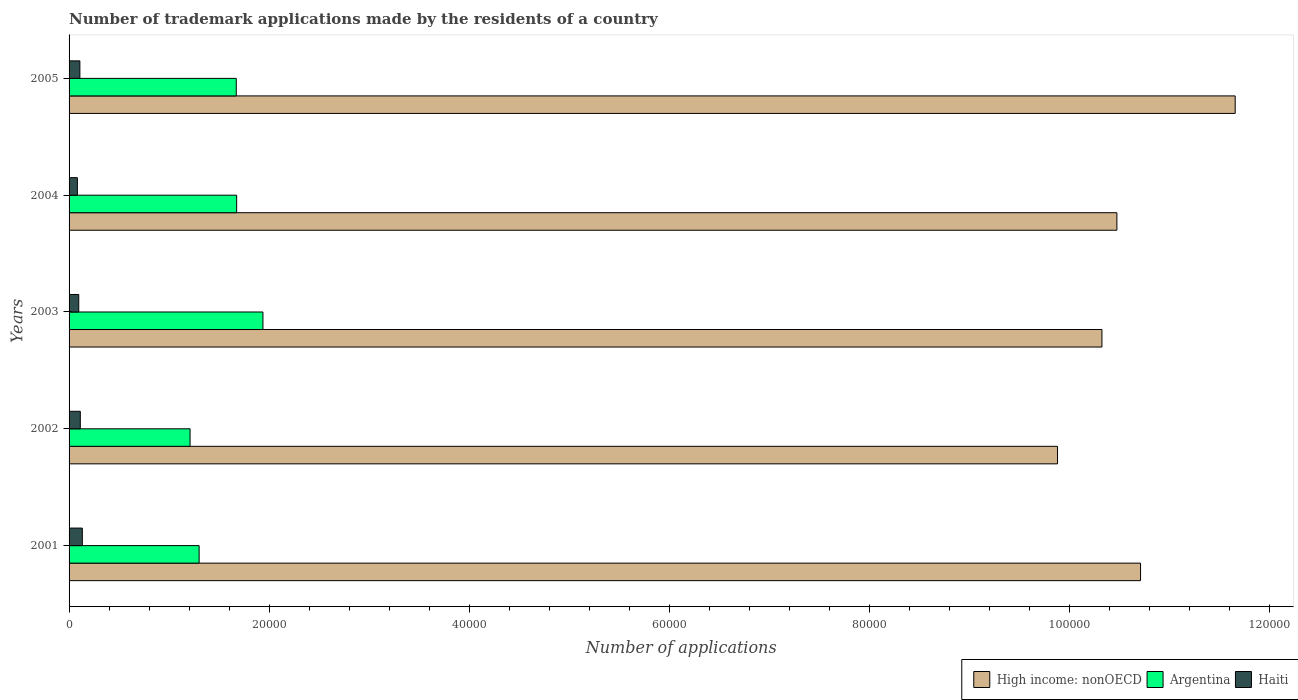Are the number of bars per tick equal to the number of legend labels?
Offer a terse response. Yes. Are the number of bars on each tick of the Y-axis equal?
Keep it short and to the point. Yes. What is the number of trademark applications made by the residents in Argentina in 2005?
Make the answer very short. 1.67e+04. Across all years, what is the maximum number of trademark applications made by the residents in Argentina?
Offer a very short reply. 1.94e+04. Across all years, what is the minimum number of trademark applications made by the residents in High income: nonOECD?
Offer a very short reply. 9.88e+04. In which year was the number of trademark applications made by the residents in Argentina minimum?
Offer a very short reply. 2002. What is the total number of trademark applications made by the residents in High income: nonOECD in the graph?
Make the answer very short. 5.30e+05. What is the difference between the number of trademark applications made by the residents in High income: nonOECD in 2001 and that in 2005?
Provide a short and direct response. -9458. What is the difference between the number of trademark applications made by the residents in Haiti in 2004 and the number of trademark applications made by the residents in High income: nonOECD in 2001?
Provide a short and direct response. -1.06e+05. What is the average number of trademark applications made by the residents in Argentina per year?
Your answer should be compact. 1.56e+04. In the year 2003, what is the difference between the number of trademark applications made by the residents in Haiti and number of trademark applications made by the residents in High income: nonOECD?
Keep it short and to the point. -1.02e+05. In how many years, is the number of trademark applications made by the residents in Haiti greater than 112000 ?
Offer a terse response. 0. What is the ratio of the number of trademark applications made by the residents in Argentina in 2001 to that in 2004?
Your response must be concise. 0.78. Is the number of trademark applications made by the residents in Argentina in 2001 less than that in 2004?
Your answer should be very brief. Yes. What is the difference between the highest and the second highest number of trademark applications made by the residents in High income: nonOECD?
Keep it short and to the point. 9458. What is the difference between the highest and the lowest number of trademark applications made by the residents in Haiti?
Your answer should be compact. 495. What does the 1st bar from the top in 2001 represents?
Your answer should be compact. Haiti. What does the 2nd bar from the bottom in 2002 represents?
Offer a terse response. Argentina. Is it the case that in every year, the sum of the number of trademark applications made by the residents in Argentina and number of trademark applications made by the residents in High income: nonOECD is greater than the number of trademark applications made by the residents in Haiti?
Keep it short and to the point. Yes. How many bars are there?
Give a very brief answer. 15. How many years are there in the graph?
Your response must be concise. 5. What is the difference between two consecutive major ticks on the X-axis?
Offer a very short reply. 2.00e+04. Does the graph contain grids?
Offer a terse response. No. Where does the legend appear in the graph?
Your answer should be very brief. Bottom right. How many legend labels are there?
Your answer should be very brief. 3. How are the legend labels stacked?
Provide a short and direct response. Horizontal. What is the title of the graph?
Provide a succinct answer. Number of trademark applications made by the residents of a country. Does "Mozambique" appear as one of the legend labels in the graph?
Provide a succinct answer. No. What is the label or title of the X-axis?
Offer a very short reply. Number of applications. What is the Number of applications in High income: nonOECD in 2001?
Ensure brevity in your answer.  1.07e+05. What is the Number of applications in Argentina in 2001?
Provide a succinct answer. 1.30e+04. What is the Number of applications of Haiti in 2001?
Your answer should be compact. 1325. What is the Number of applications in High income: nonOECD in 2002?
Provide a succinct answer. 9.88e+04. What is the Number of applications in Argentina in 2002?
Your answer should be very brief. 1.21e+04. What is the Number of applications of Haiti in 2002?
Provide a short and direct response. 1122. What is the Number of applications of High income: nonOECD in 2003?
Give a very brief answer. 1.03e+05. What is the Number of applications in Argentina in 2003?
Offer a very short reply. 1.94e+04. What is the Number of applications of Haiti in 2003?
Your answer should be compact. 967. What is the Number of applications in High income: nonOECD in 2004?
Give a very brief answer. 1.05e+05. What is the Number of applications of Argentina in 2004?
Keep it short and to the point. 1.67e+04. What is the Number of applications in Haiti in 2004?
Give a very brief answer. 830. What is the Number of applications in High income: nonOECD in 2005?
Give a very brief answer. 1.17e+05. What is the Number of applications of Argentina in 2005?
Your response must be concise. 1.67e+04. What is the Number of applications in Haiti in 2005?
Your answer should be very brief. 1079. Across all years, what is the maximum Number of applications of High income: nonOECD?
Provide a short and direct response. 1.17e+05. Across all years, what is the maximum Number of applications of Argentina?
Make the answer very short. 1.94e+04. Across all years, what is the maximum Number of applications in Haiti?
Make the answer very short. 1325. Across all years, what is the minimum Number of applications of High income: nonOECD?
Provide a short and direct response. 9.88e+04. Across all years, what is the minimum Number of applications in Argentina?
Offer a very short reply. 1.21e+04. Across all years, what is the minimum Number of applications of Haiti?
Offer a very short reply. 830. What is the total Number of applications in High income: nonOECD in the graph?
Keep it short and to the point. 5.30e+05. What is the total Number of applications of Argentina in the graph?
Offer a terse response. 7.79e+04. What is the total Number of applications of Haiti in the graph?
Provide a succinct answer. 5323. What is the difference between the Number of applications in High income: nonOECD in 2001 and that in 2002?
Your answer should be very brief. 8296. What is the difference between the Number of applications of Argentina in 2001 and that in 2002?
Your response must be concise. 905. What is the difference between the Number of applications in Haiti in 2001 and that in 2002?
Offer a very short reply. 203. What is the difference between the Number of applications in High income: nonOECD in 2001 and that in 2003?
Offer a terse response. 3858. What is the difference between the Number of applications in Argentina in 2001 and that in 2003?
Your response must be concise. -6377. What is the difference between the Number of applications of Haiti in 2001 and that in 2003?
Give a very brief answer. 358. What is the difference between the Number of applications in High income: nonOECD in 2001 and that in 2004?
Your response must be concise. 2363. What is the difference between the Number of applications in Argentina in 2001 and that in 2004?
Your answer should be compact. -3752. What is the difference between the Number of applications in Haiti in 2001 and that in 2004?
Offer a very short reply. 495. What is the difference between the Number of applications in High income: nonOECD in 2001 and that in 2005?
Give a very brief answer. -9458. What is the difference between the Number of applications of Argentina in 2001 and that in 2005?
Your response must be concise. -3712. What is the difference between the Number of applications in Haiti in 2001 and that in 2005?
Your answer should be compact. 246. What is the difference between the Number of applications in High income: nonOECD in 2002 and that in 2003?
Your answer should be very brief. -4438. What is the difference between the Number of applications in Argentina in 2002 and that in 2003?
Offer a terse response. -7282. What is the difference between the Number of applications in Haiti in 2002 and that in 2003?
Offer a terse response. 155. What is the difference between the Number of applications of High income: nonOECD in 2002 and that in 2004?
Offer a terse response. -5933. What is the difference between the Number of applications in Argentina in 2002 and that in 2004?
Offer a very short reply. -4657. What is the difference between the Number of applications of Haiti in 2002 and that in 2004?
Your answer should be very brief. 292. What is the difference between the Number of applications in High income: nonOECD in 2002 and that in 2005?
Ensure brevity in your answer.  -1.78e+04. What is the difference between the Number of applications of Argentina in 2002 and that in 2005?
Ensure brevity in your answer.  -4617. What is the difference between the Number of applications of High income: nonOECD in 2003 and that in 2004?
Make the answer very short. -1495. What is the difference between the Number of applications in Argentina in 2003 and that in 2004?
Provide a short and direct response. 2625. What is the difference between the Number of applications in Haiti in 2003 and that in 2004?
Your answer should be very brief. 137. What is the difference between the Number of applications in High income: nonOECD in 2003 and that in 2005?
Make the answer very short. -1.33e+04. What is the difference between the Number of applications in Argentina in 2003 and that in 2005?
Your answer should be very brief. 2665. What is the difference between the Number of applications in Haiti in 2003 and that in 2005?
Ensure brevity in your answer.  -112. What is the difference between the Number of applications in High income: nonOECD in 2004 and that in 2005?
Keep it short and to the point. -1.18e+04. What is the difference between the Number of applications of Argentina in 2004 and that in 2005?
Provide a short and direct response. 40. What is the difference between the Number of applications of Haiti in 2004 and that in 2005?
Keep it short and to the point. -249. What is the difference between the Number of applications of High income: nonOECD in 2001 and the Number of applications of Argentina in 2002?
Ensure brevity in your answer.  9.50e+04. What is the difference between the Number of applications of High income: nonOECD in 2001 and the Number of applications of Haiti in 2002?
Keep it short and to the point. 1.06e+05. What is the difference between the Number of applications in Argentina in 2001 and the Number of applications in Haiti in 2002?
Offer a very short reply. 1.19e+04. What is the difference between the Number of applications of High income: nonOECD in 2001 and the Number of applications of Argentina in 2003?
Keep it short and to the point. 8.77e+04. What is the difference between the Number of applications in High income: nonOECD in 2001 and the Number of applications in Haiti in 2003?
Provide a succinct answer. 1.06e+05. What is the difference between the Number of applications in Argentina in 2001 and the Number of applications in Haiti in 2003?
Offer a terse response. 1.20e+04. What is the difference between the Number of applications in High income: nonOECD in 2001 and the Number of applications in Argentina in 2004?
Ensure brevity in your answer.  9.03e+04. What is the difference between the Number of applications of High income: nonOECD in 2001 and the Number of applications of Haiti in 2004?
Keep it short and to the point. 1.06e+05. What is the difference between the Number of applications of Argentina in 2001 and the Number of applications of Haiti in 2004?
Offer a terse response. 1.22e+04. What is the difference between the Number of applications of High income: nonOECD in 2001 and the Number of applications of Argentina in 2005?
Give a very brief answer. 9.04e+04. What is the difference between the Number of applications in High income: nonOECD in 2001 and the Number of applications in Haiti in 2005?
Keep it short and to the point. 1.06e+05. What is the difference between the Number of applications of Argentina in 2001 and the Number of applications of Haiti in 2005?
Make the answer very short. 1.19e+04. What is the difference between the Number of applications of High income: nonOECD in 2002 and the Number of applications of Argentina in 2003?
Provide a short and direct response. 7.94e+04. What is the difference between the Number of applications in High income: nonOECD in 2002 and the Number of applications in Haiti in 2003?
Your answer should be compact. 9.78e+04. What is the difference between the Number of applications of Argentina in 2002 and the Number of applications of Haiti in 2003?
Give a very brief answer. 1.11e+04. What is the difference between the Number of applications of High income: nonOECD in 2002 and the Number of applications of Argentina in 2004?
Provide a short and direct response. 8.20e+04. What is the difference between the Number of applications of High income: nonOECD in 2002 and the Number of applications of Haiti in 2004?
Ensure brevity in your answer.  9.80e+04. What is the difference between the Number of applications of Argentina in 2002 and the Number of applications of Haiti in 2004?
Keep it short and to the point. 1.13e+04. What is the difference between the Number of applications in High income: nonOECD in 2002 and the Number of applications in Argentina in 2005?
Give a very brief answer. 8.21e+04. What is the difference between the Number of applications of High income: nonOECD in 2002 and the Number of applications of Haiti in 2005?
Make the answer very short. 9.77e+04. What is the difference between the Number of applications of Argentina in 2002 and the Number of applications of Haiti in 2005?
Provide a succinct answer. 1.10e+04. What is the difference between the Number of applications in High income: nonOECD in 2003 and the Number of applications in Argentina in 2004?
Your response must be concise. 8.65e+04. What is the difference between the Number of applications of High income: nonOECD in 2003 and the Number of applications of Haiti in 2004?
Offer a terse response. 1.02e+05. What is the difference between the Number of applications of Argentina in 2003 and the Number of applications of Haiti in 2004?
Ensure brevity in your answer.  1.85e+04. What is the difference between the Number of applications of High income: nonOECD in 2003 and the Number of applications of Argentina in 2005?
Your answer should be compact. 8.65e+04. What is the difference between the Number of applications in High income: nonOECD in 2003 and the Number of applications in Haiti in 2005?
Your answer should be compact. 1.02e+05. What is the difference between the Number of applications of Argentina in 2003 and the Number of applications of Haiti in 2005?
Offer a very short reply. 1.83e+04. What is the difference between the Number of applications of High income: nonOECD in 2004 and the Number of applications of Argentina in 2005?
Your answer should be compact. 8.80e+04. What is the difference between the Number of applications in High income: nonOECD in 2004 and the Number of applications in Haiti in 2005?
Make the answer very short. 1.04e+05. What is the difference between the Number of applications in Argentina in 2004 and the Number of applications in Haiti in 2005?
Your answer should be compact. 1.57e+04. What is the average Number of applications of High income: nonOECD per year?
Keep it short and to the point. 1.06e+05. What is the average Number of applications of Argentina per year?
Ensure brevity in your answer.  1.56e+04. What is the average Number of applications in Haiti per year?
Your answer should be very brief. 1064.6. In the year 2001, what is the difference between the Number of applications of High income: nonOECD and Number of applications of Argentina?
Make the answer very short. 9.41e+04. In the year 2001, what is the difference between the Number of applications in High income: nonOECD and Number of applications in Haiti?
Make the answer very short. 1.06e+05. In the year 2001, what is the difference between the Number of applications of Argentina and Number of applications of Haiti?
Offer a very short reply. 1.17e+04. In the year 2002, what is the difference between the Number of applications in High income: nonOECD and Number of applications in Argentina?
Give a very brief answer. 8.67e+04. In the year 2002, what is the difference between the Number of applications of High income: nonOECD and Number of applications of Haiti?
Offer a very short reply. 9.77e+04. In the year 2002, what is the difference between the Number of applications in Argentina and Number of applications in Haiti?
Make the answer very short. 1.10e+04. In the year 2003, what is the difference between the Number of applications of High income: nonOECD and Number of applications of Argentina?
Offer a terse response. 8.38e+04. In the year 2003, what is the difference between the Number of applications of High income: nonOECD and Number of applications of Haiti?
Your answer should be very brief. 1.02e+05. In the year 2003, what is the difference between the Number of applications of Argentina and Number of applications of Haiti?
Provide a short and direct response. 1.84e+04. In the year 2004, what is the difference between the Number of applications in High income: nonOECD and Number of applications in Argentina?
Give a very brief answer. 8.80e+04. In the year 2004, what is the difference between the Number of applications in High income: nonOECD and Number of applications in Haiti?
Make the answer very short. 1.04e+05. In the year 2004, what is the difference between the Number of applications in Argentina and Number of applications in Haiti?
Your answer should be compact. 1.59e+04. In the year 2005, what is the difference between the Number of applications of High income: nonOECD and Number of applications of Argentina?
Your response must be concise. 9.98e+04. In the year 2005, what is the difference between the Number of applications in High income: nonOECD and Number of applications in Haiti?
Ensure brevity in your answer.  1.15e+05. In the year 2005, what is the difference between the Number of applications of Argentina and Number of applications of Haiti?
Give a very brief answer. 1.56e+04. What is the ratio of the Number of applications in High income: nonOECD in 2001 to that in 2002?
Offer a terse response. 1.08. What is the ratio of the Number of applications in Argentina in 2001 to that in 2002?
Ensure brevity in your answer.  1.07. What is the ratio of the Number of applications of Haiti in 2001 to that in 2002?
Provide a short and direct response. 1.18. What is the ratio of the Number of applications in High income: nonOECD in 2001 to that in 2003?
Ensure brevity in your answer.  1.04. What is the ratio of the Number of applications in Argentina in 2001 to that in 2003?
Provide a short and direct response. 0.67. What is the ratio of the Number of applications in Haiti in 2001 to that in 2003?
Keep it short and to the point. 1.37. What is the ratio of the Number of applications in High income: nonOECD in 2001 to that in 2004?
Provide a succinct answer. 1.02. What is the ratio of the Number of applications of Argentina in 2001 to that in 2004?
Keep it short and to the point. 0.78. What is the ratio of the Number of applications of Haiti in 2001 to that in 2004?
Keep it short and to the point. 1.6. What is the ratio of the Number of applications in High income: nonOECD in 2001 to that in 2005?
Give a very brief answer. 0.92. What is the ratio of the Number of applications of Haiti in 2001 to that in 2005?
Offer a very short reply. 1.23. What is the ratio of the Number of applications in Argentina in 2002 to that in 2003?
Offer a very short reply. 0.62. What is the ratio of the Number of applications in Haiti in 2002 to that in 2003?
Your answer should be compact. 1.16. What is the ratio of the Number of applications in High income: nonOECD in 2002 to that in 2004?
Make the answer very short. 0.94. What is the ratio of the Number of applications of Argentina in 2002 to that in 2004?
Offer a very short reply. 0.72. What is the ratio of the Number of applications of Haiti in 2002 to that in 2004?
Your answer should be very brief. 1.35. What is the ratio of the Number of applications in High income: nonOECD in 2002 to that in 2005?
Provide a succinct answer. 0.85. What is the ratio of the Number of applications in Argentina in 2002 to that in 2005?
Give a very brief answer. 0.72. What is the ratio of the Number of applications of Haiti in 2002 to that in 2005?
Your answer should be compact. 1.04. What is the ratio of the Number of applications in High income: nonOECD in 2003 to that in 2004?
Provide a succinct answer. 0.99. What is the ratio of the Number of applications in Argentina in 2003 to that in 2004?
Provide a short and direct response. 1.16. What is the ratio of the Number of applications in Haiti in 2003 to that in 2004?
Provide a short and direct response. 1.17. What is the ratio of the Number of applications of High income: nonOECD in 2003 to that in 2005?
Your response must be concise. 0.89. What is the ratio of the Number of applications of Argentina in 2003 to that in 2005?
Ensure brevity in your answer.  1.16. What is the ratio of the Number of applications in Haiti in 2003 to that in 2005?
Offer a terse response. 0.9. What is the ratio of the Number of applications of High income: nonOECD in 2004 to that in 2005?
Ensure brevity in your answer.  0.9. What is the ratio of the Number of applications of Argentina in 2004 to that in 2005?
Offer a very short reply. 1. What is the ratio of the Number of applications in Haiti in 2004 to that in 2005?
Your answer should be compact. 0.77. What is the difference between the highest and the second highest Number of applications of High income: nonOECD?
Provide a short and direct response. 9458. What is the difference between the highest and the second highest Number of applications in Argentina?
Ensure brevity in your answer.  2625. What is the difference between the highest and the second highest Number of applications in Haiti?
Your answer should be compact. 203. What is the difference between the highest and the lowest Number of applications of High income: nonOECD?
Your response must be concise. 1.78e+04. What is the difference between the highest and the lowest Number of applications in Argentina?
Your response must be concise. 7282. What is the difference between the highest and the lowest Number of applications of Haiti?
Offer a terse response. 495. 